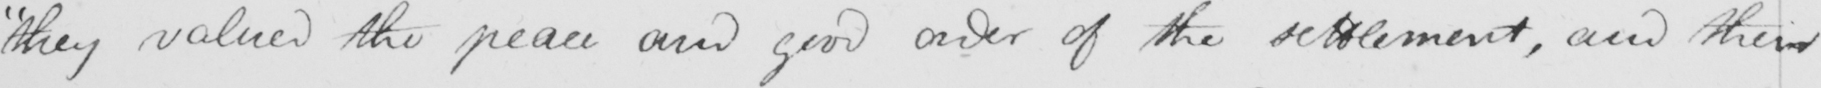Can you read and transcribe this handwriting? "they valued the peace and good order of the settlement, and their 